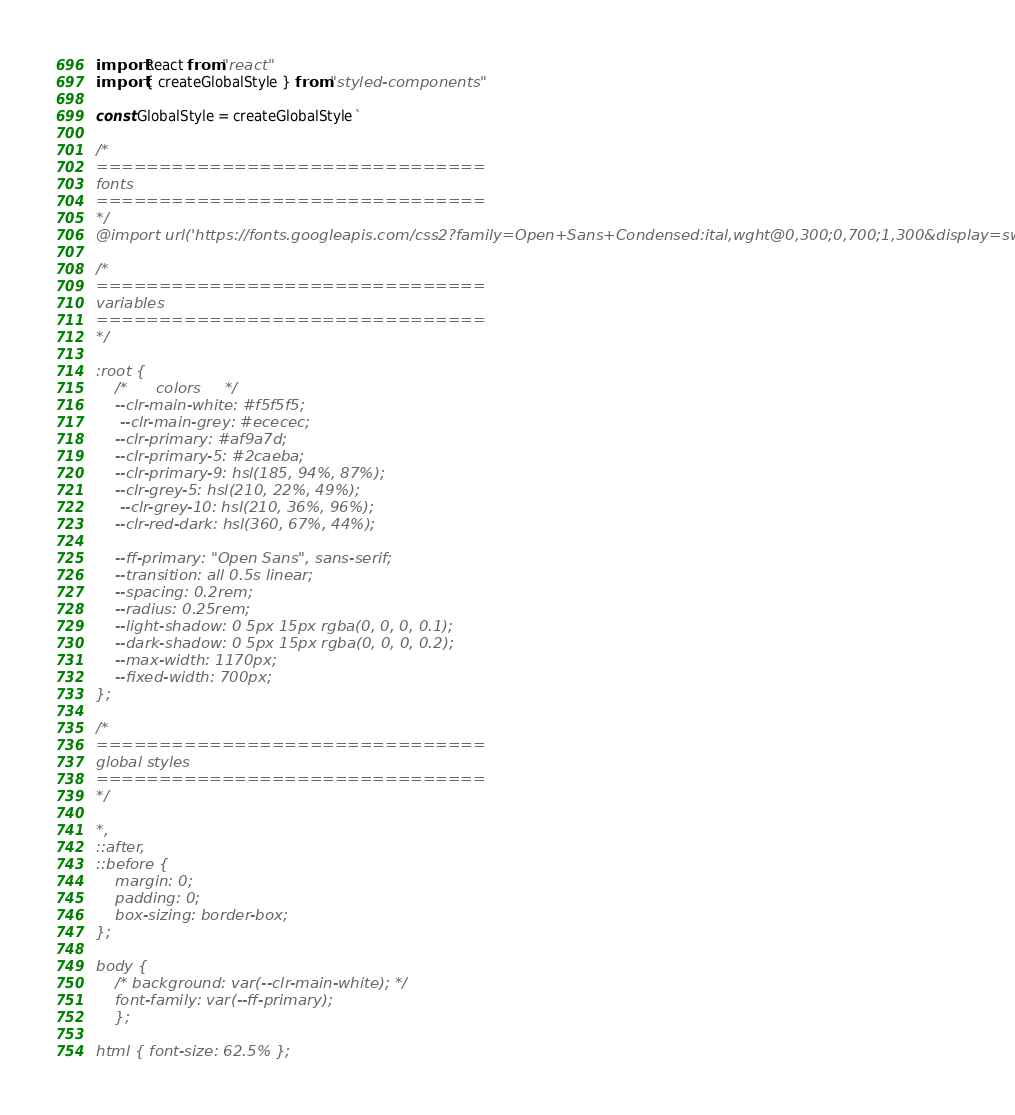Convert code to text. <code><loc_0><loc_0><loc_500><loc_500><_JavaScript_>import React from "react"
import { createGlobalStyle } from "styled-components"

const GlobalStyle = createGlobalStyle`

/* 
===============================
fonts
===============================
*/
@import url('https://fonts.googleapis.com/css2?family=Open+Sans+Condensed:ital,wght@0,300;0,700;1,300&display=swap');

/* 
===============================
variables
===============================
*/

:root {
    /*      colors     */
    --clr-main-white: #f5f5f5;
     --clr-main-grey: #ececec;
    --clr-primary: #af9a7d;
    --clr-primary-5: #2caeba;
    --clr-primary-9: hsl(185, 94%, 87%);
    --clr-grey-5: hsl(210, 22%, 49%);
     --clr-grey-10: hsl(210, 36%, 96%);
    --clr-red-dark: hsl(360, 67%, 44%);

    --ff-primary: "Open Sans", sans-serif;
    --transition: all 0.5s linear;
    --spacing: 0.2rem;
    --radius: 0.25rem;
    --light-shadow: 0 5px 15px rgba(0, 0, 0, 0.1);
    --dark-shadow: 0 5px 15px rgba(0, 0, 0, 0.2);
    --max-width: 1170px;
    --fixed-width: 700px;
};

/*
===============================
global styles
===============================
*/

*,
::after,
::before {
    margin: 0;
    padding: 0;
    box-sizing: border-box;
};

body { 
    /* background: var(--clr-main-white); */
    font-family: var(--ff-primary);
    };

html { font-size: 62.5% };
</code> 